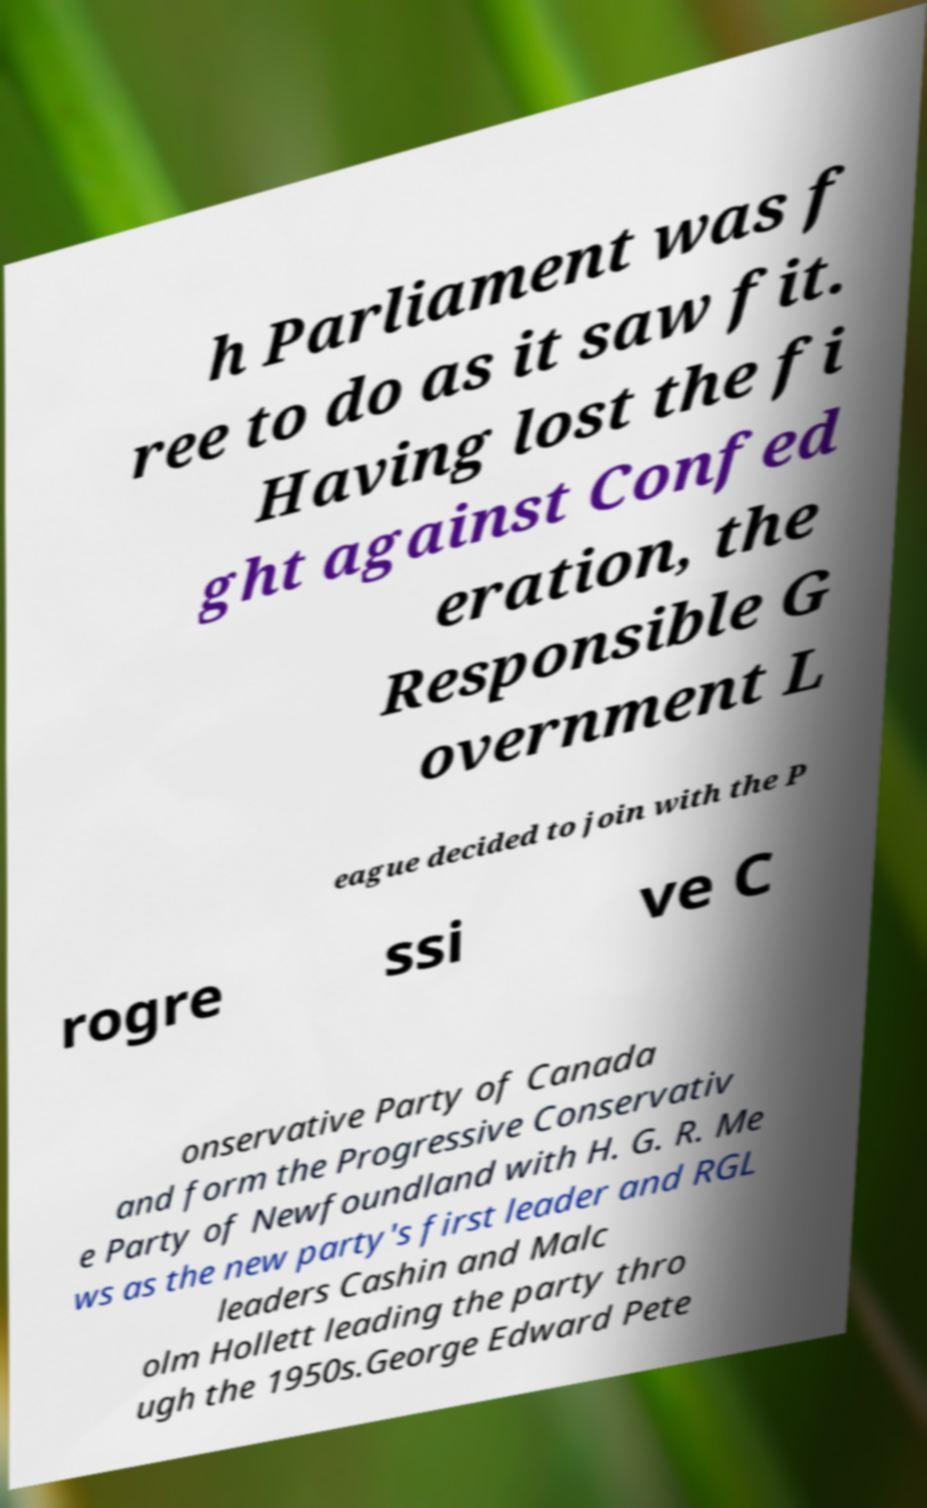Please read and relay the text visible in this image. What does it say? h Parliament was f ree to do as it saw fit. Having lost the fi ght against Confed eration, the Responsible G overnment L eague decided to join with the P rogre ssi ve C onservative Party of Canada and form the Progressive Conservativ e Party of Newfoundland with H. G. R. Me ws as the new party's first leader and RGL leaders Cashin and Malc olm Hollett leading the party thro ugh the 1950s.George Edward Pete 